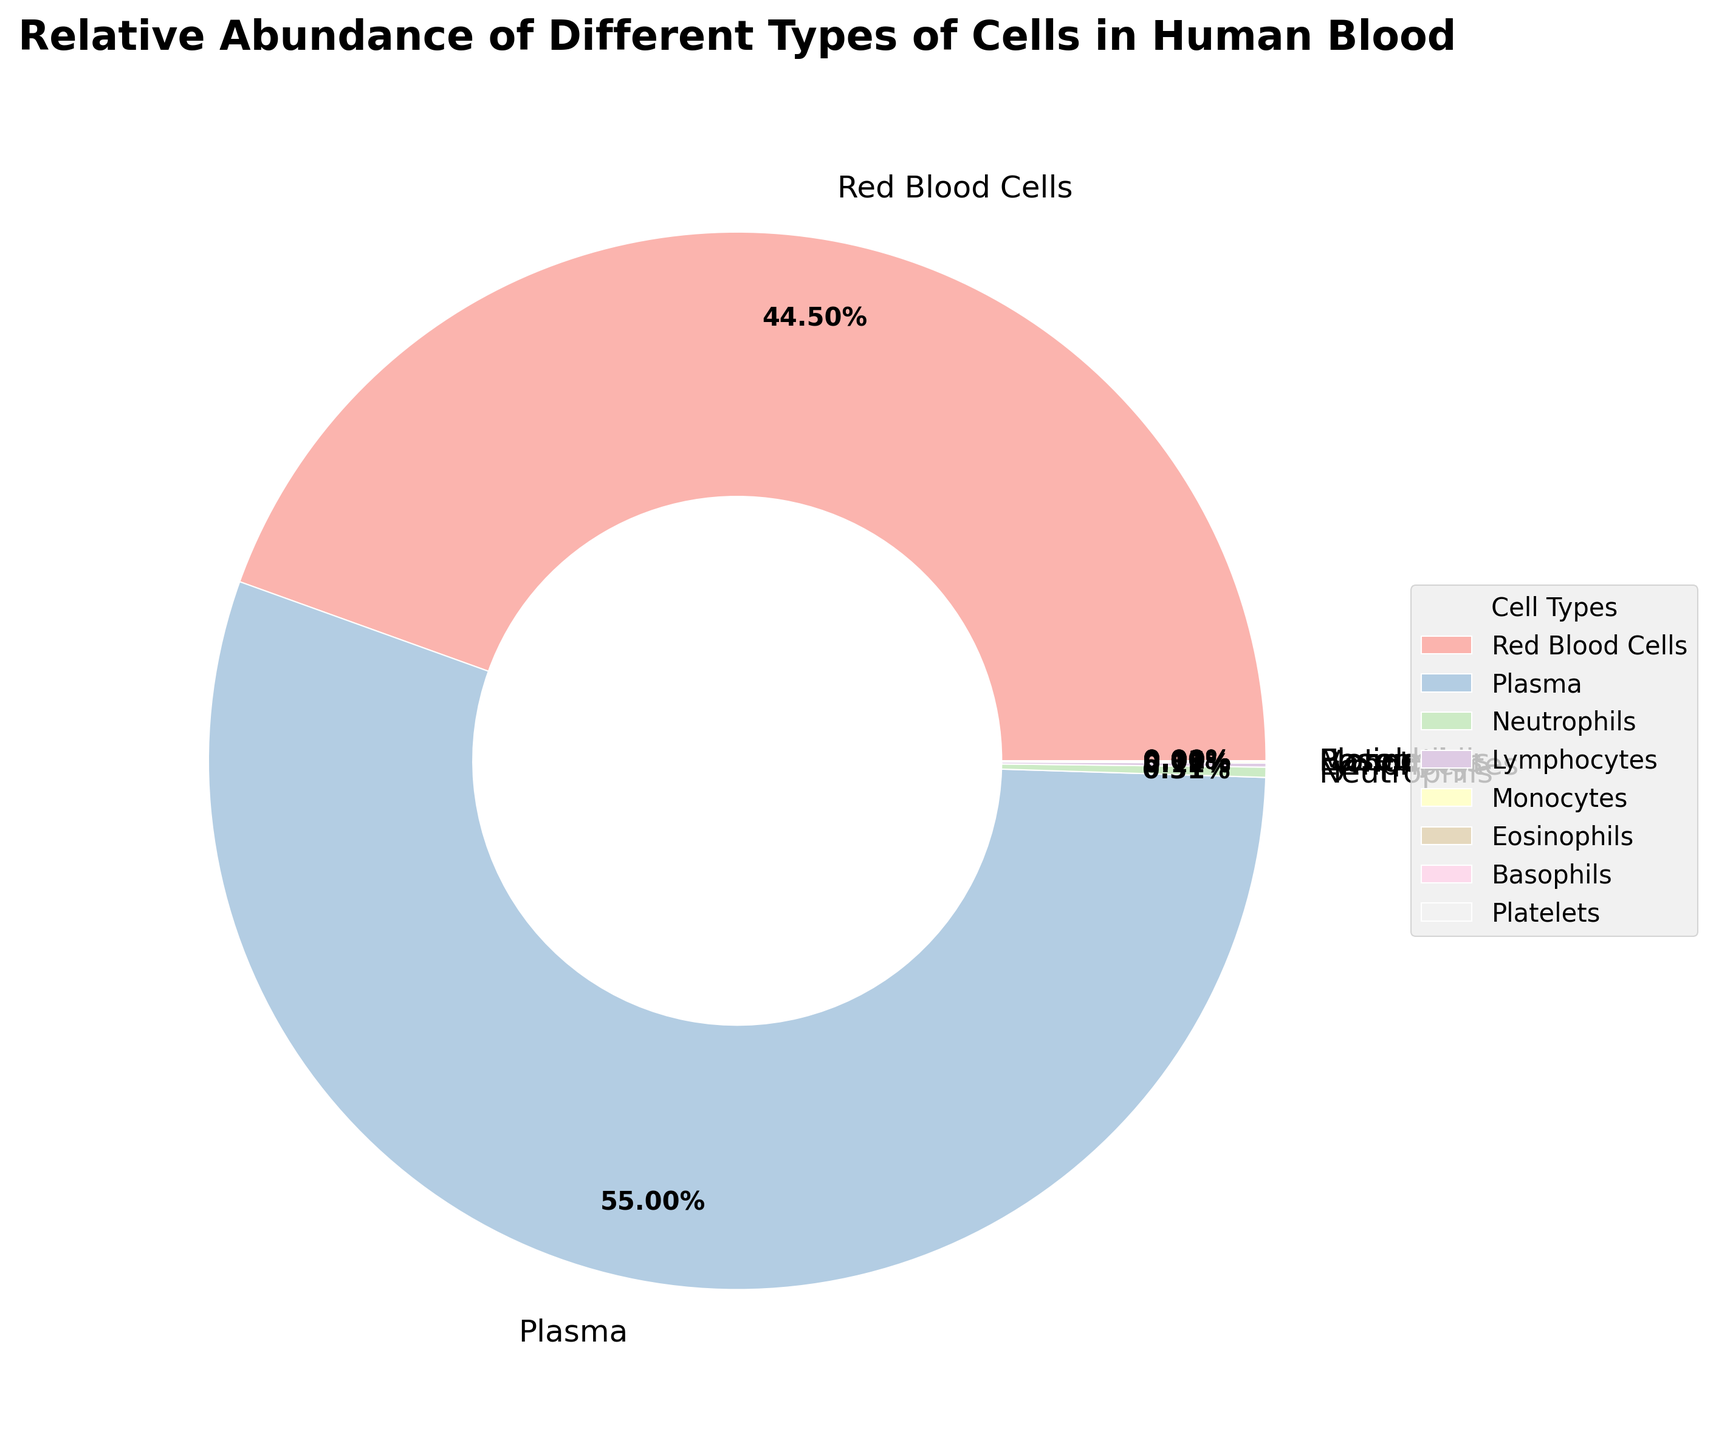Which type of cell has the largest relative abundance in human blood according to the pie chart? The pie chart indicates that plasma has the largest relative abundance with a percentage of 55.0%.
Answer: Plasma Which two cell types together make up nearly 100% of the blood volume? The sum of the percentages of plasma (55.0%) and red blood cells (44.5%) is 55.0 + 44.5 = 99.5%, which is nearly 100%.
Answer: Plasma and Red Blood Cells Which cell type has the smallest relative abundance, and what is its percentage? The pie chart shows that basophils and platelets have the smallest relative abundance, each with a percentage of 0.005%.
Answer: Basophils and Platelets, 0.005% How does the relative abundance of neutrophils compare to that of lymphocytes? The pie chart shows that neutrophils have a greater abundance (0.31%) compared to lymphocytes (0.12%).
Answer: Neutrophils have a greater abundance than lymphocytes What is the combined relative abundance of eosinophils and basophils? The pie chart indicates that eosinophils have 0.01% and basophils have 0.005%. Summing these values gives 0.01 + 0.005 = 0.015%.
Answer: 0.015% By looking at the colors, identify which two cell types have the closest visual size in the chart and state their percentages. The wedges for lymphocytes (0.12%) and monocytes (0.05%) appear closest in size visually, due to their small proportions in the chart.
Answer: Lymphocytes, 0.12% and Monocytes, 0.05% What is the relative abundance of cells other than plasma and red blood cells? Excluding plasma (55.0%) and red blood cells (44.5%), the remaining percentages add up as follows: 0.31 (neutrophils) + 0.12 (lymphocytes) + 0.05 (monocytes) + 0.01 (eosinophils) + 0.005 (basophils) + 0.005 (platelets) = 0.495%.
Answer: 0.495% Compare the combined percentage of neutrophils and lymphocytes with the percentage of monocytes. Which is greater? Neutrophils (0.31%) combined with lymphocytes (0.12%) gives 0.31 + 0.12 = 0.43%. This is greater than the percentage of monocytes, which is 0.05%.
Answer: Neutrophils and lymphocytes combined If the percentage of red blood cells decreased by 5%, what would their new percentage be? The current percentage for red blood cells is 44.5%. If it decreased by 5%, it would be 44.5 - 5 = 39.5%.
Answer: 39.5% 